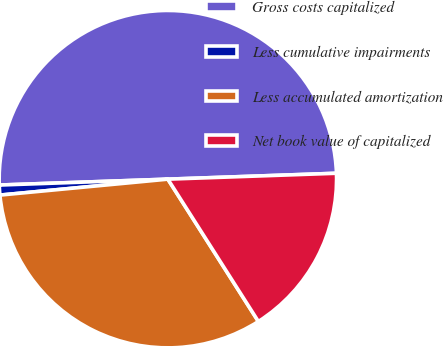<chart> <loc_0><loc_0><loc_500><loc_500><pie_chart><fcel>Gross costs capitalized<fcel>Less cumulative impairments<fcel>Less accumulated amortization<fcel>Net book value of capitalized<nl><fcel>50.0%<fcel>0.95%<fcel>32.51%<fcel>16.54%<nl></chart> 